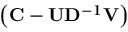<formula> <loc_0><loc_0><loc_500><loc_500>\left ( C - U D ^ { - 1 } V \right )</formula> 